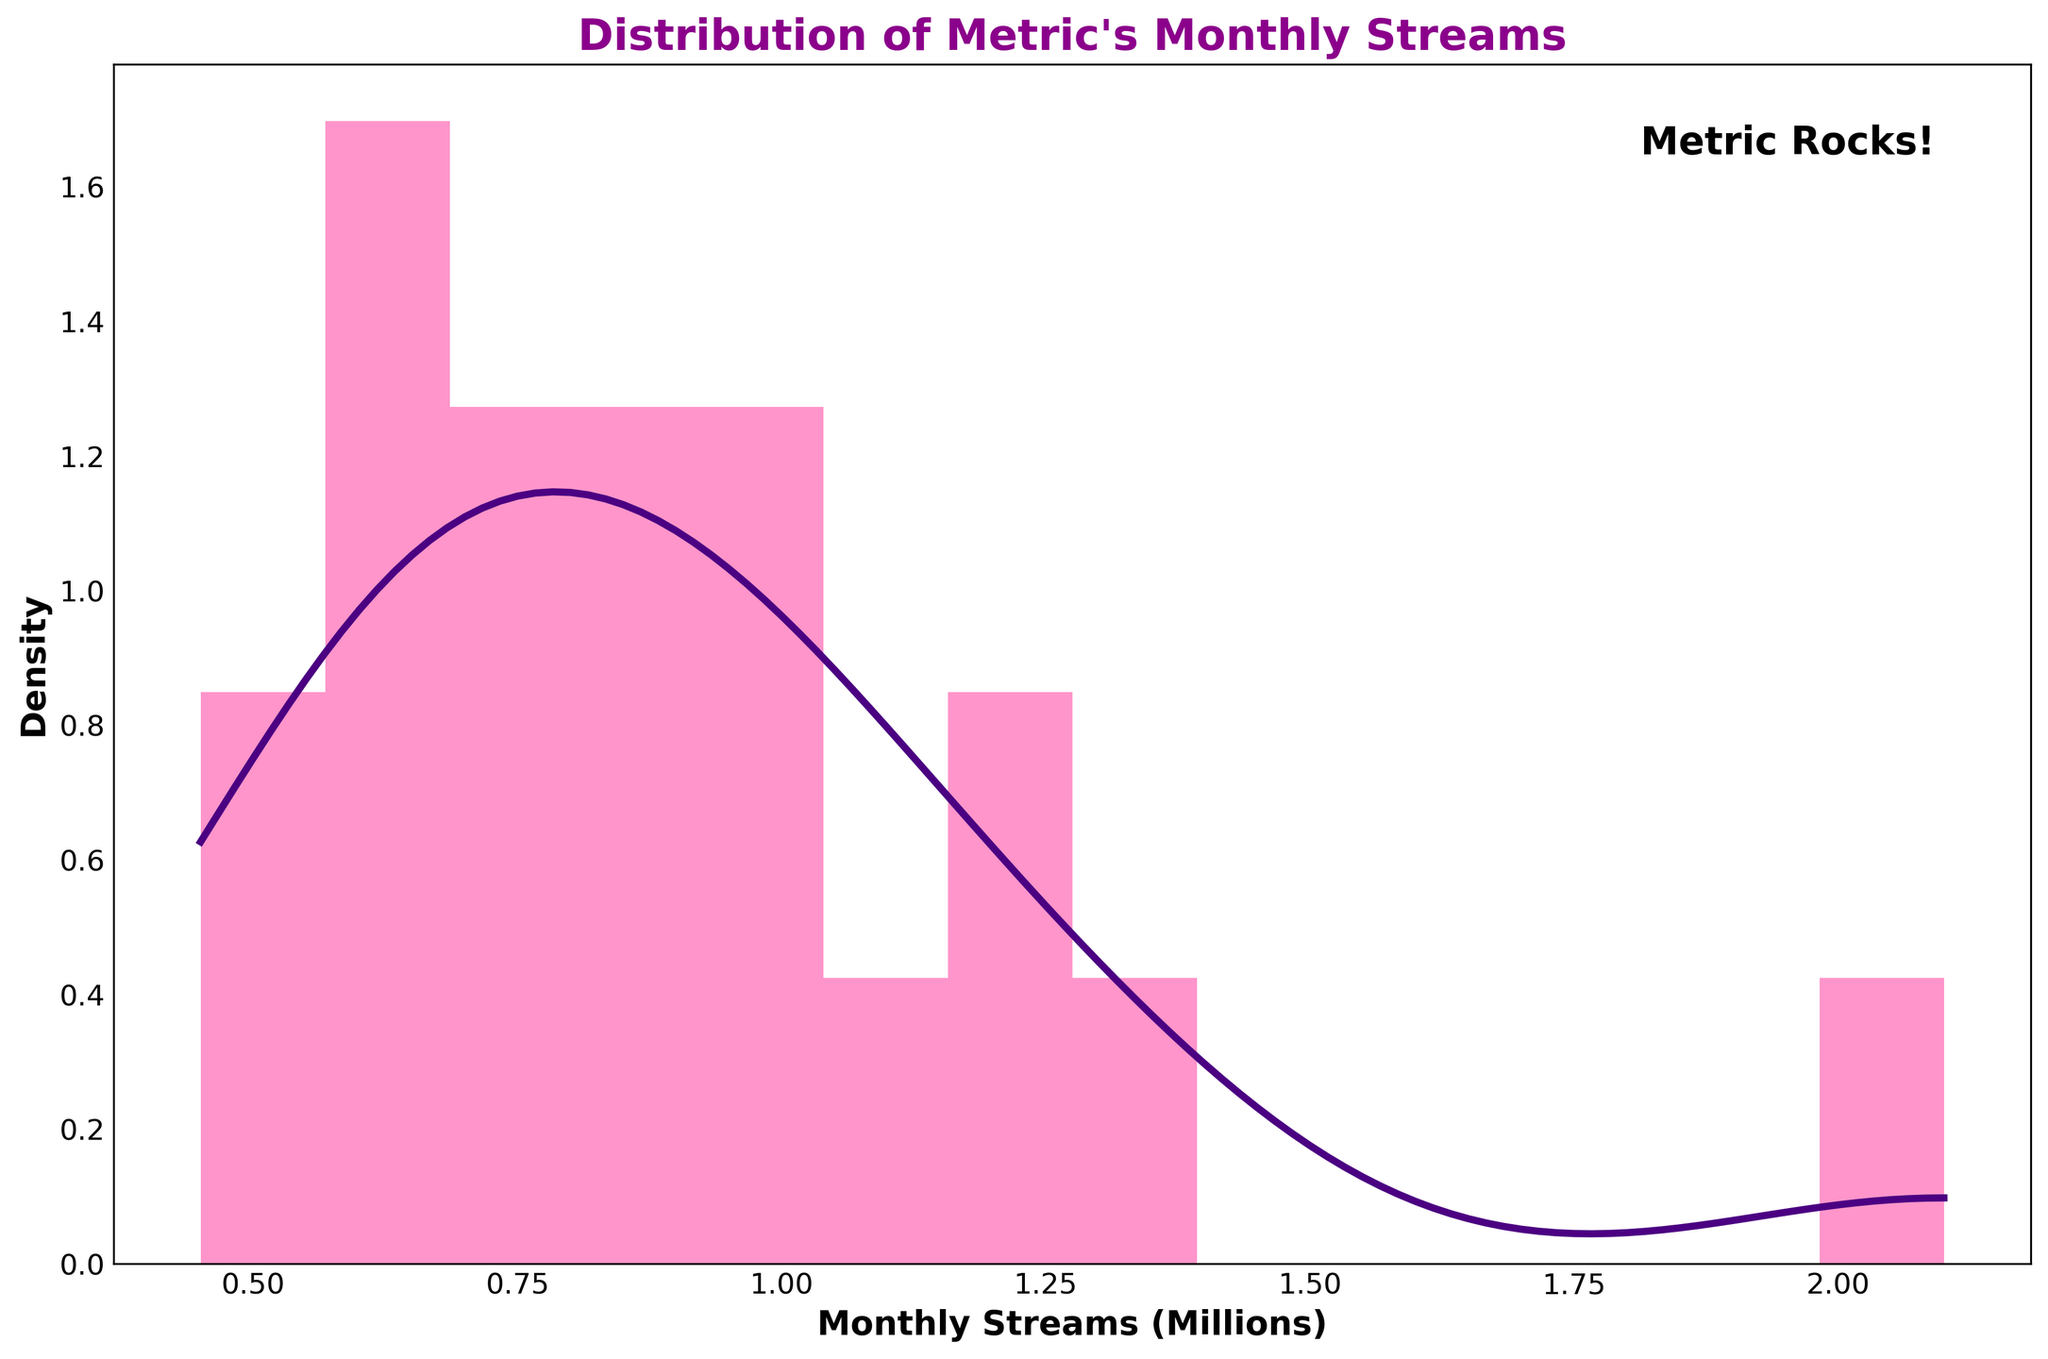What is the title of the figure? The title is displayed prominently at the top of the figure in bold and colorful text.
Answer: Distribution of Metric's Monthly Streams How many histogram bins are used in the figure? The number of vertical bars (bins) in the histogram can be counted directly.
Answer: 14 What range of monthly streams is covered by the histogram in the figure? The x-axis labels indicate the range of streams covered in the figure. The minimum and maximum ticks can be read directly.
Answer: Approximately 0.45 to 2.1 million Which song interval contains the highest density of monthly streams based on the KDE curve? The peak of the density curve (KDE) indicates the interval with the highest density of streams.
Answer: 1.0 to 1.4 million What is the approximate density at the peak of the KDE curve? The y-axis value at the peak of the KDE curve can be found by observation.
Answer: Approximately 0.5 How does the number of songs with monthly streams between 0.7 million and 1 million compare to those between 1 million and 1.3 million? Count the relevant bins: count the bars falling into each range and compare their heights. The area under the KDE can also guide the comparison.
Answer: Fewer songs between 0.7 million and 1 million How many songs have over 1.5 million monthly streams? By referring to the histogram bars, count the number of bars and compare the stream values to identify the ones exceeding 1.5 million.
Answer: 2 songs Which data visualization color represents the Histogram and which represents the KDE? By looking at the colors used in the figure, we can identify the colors for each visual element.
Answer: Pink for Histogram, Purple for KDE What is the average monthly stream of all songs, considering the histogram data? Convert each bin's midpoint to actual values by multiplying by 1 million and find the average. Sum all values and divide by the number of songs.
Answer: Approximately 0.9 million 